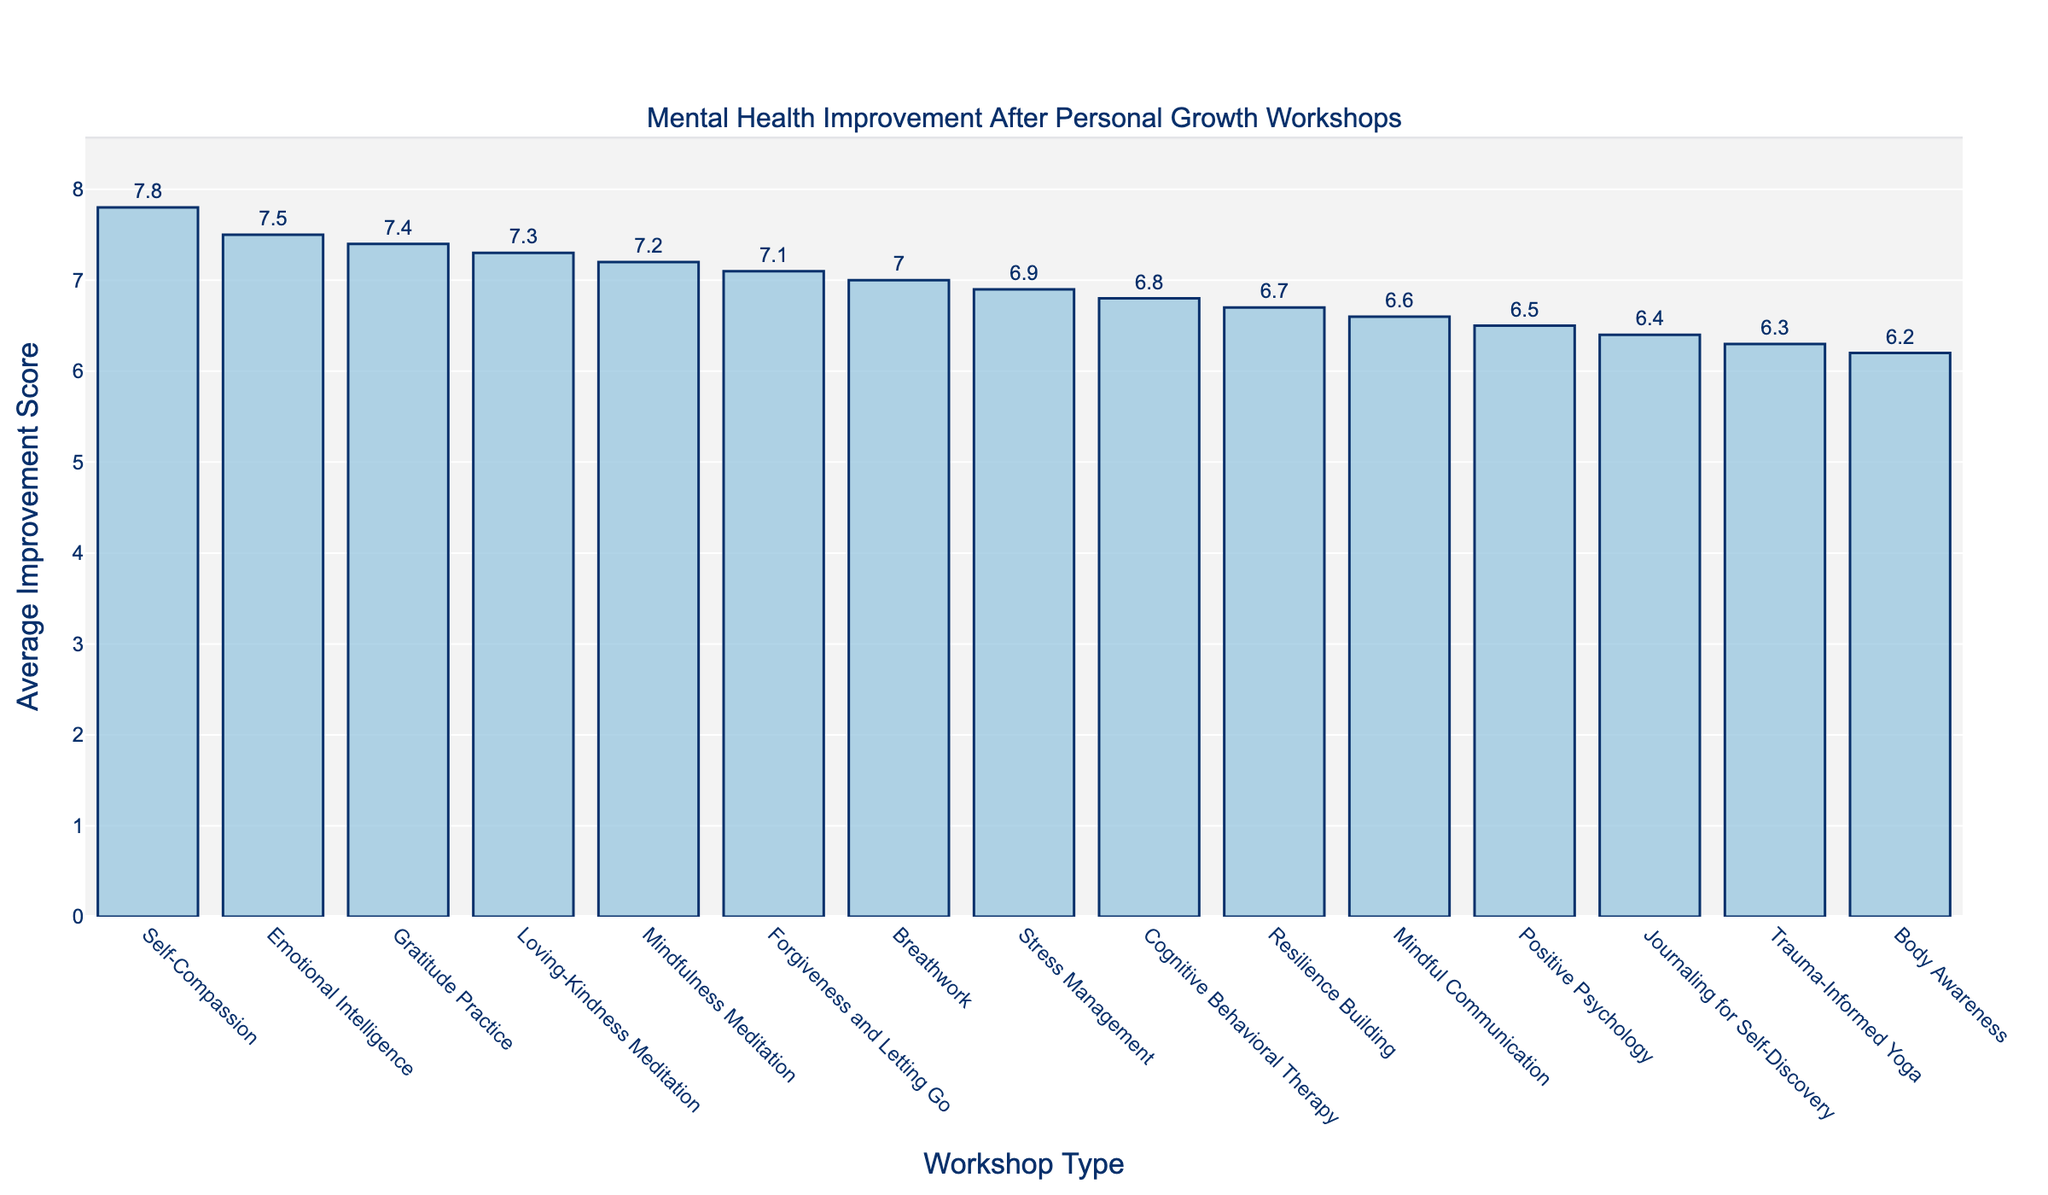Which workshop type has the highest average improvement score? The tallest bar on the chart represents the workshop type with the highest average improvement score. In this case, "Self-Compassion" has the highest bar.
Answer: Self-Compassion Which workshop type has the lowest average improvement score? The shortest bar on the chart indicates the workshop type with the lowest average improvement score. "Body Awareness" has the lowest bar.
Answer: Body Awareness How much higher is the average improvement score of Emotional Intelligence compared to Cognitive Behavioral Therapy? Locate the bars for Emotional Intelligence and Cognitive Behavioral Therapy. Emotional Intelligence has an average improvement score of 7.5, while Cognitive Behavioral Therapy has 6.8. Subtract the lower score from the higher score: 7.5 - 6.8 = 0.7.
Answer: 0.7 What is the combined average improvement score of Mindfulness Meditation and Forgiveness and Letting Go? Find the bars for Mindfulness Meditation and Forgiveness and Letting Go. Their scores are 7.2 and 7.1, respectively. Add these scores together: 7.2 + 7.1 = 14.3.
Answer: 14.3 Rank the workshop types from highest to lowest average improvement scores. Starting from the tallest bar to the shortest, the ranking is: 1) Self-Compassion, 2) Emotional Intelligence, 3) Gratitude Practice, 4) Loving-Kindness Meditation, 5) Mindfulness Meditation, 6) Forgiveness and Letting Go, 7) Breathwork, 8) Stress Management, 9) Cognitive Behavioral Therapy, 10) Resilience Building, 11) Mindful Communication, 12) Journaling for Self-Discovery, 13) Positive Psychology, 14) Body Awareness, 15) Trauma-Informed Yoga.
Answer: Self-Compassion, Emotional Intelligence, Gratitude Practice, Loving-Kindness Meditation, Mindfulness Meditation, Forgiveness and Letting Go, Breathwork, Stress Management, Cognitive Behavioral Therapy, Resilience Building, Mindful Communication, Journaling for Self-Discovery, Positive Psychology, Body Awareness, Trauma-Informed Yoga What is the average improvement score for workshops with scores above 7? Identify the workshops with scores above 7: Mindfulness Meditation (7.2), Emotional Intelligence (7.5), Self-Compassion (7.8), Forgiveness and Letting Go (7.1), Gratitude Practice (7.4), Loving-Kindness Meditation (7.3). Calculate their average: (7.2 + 7.5 + 7.8 + 7.1 + 7.4 + 7.3)/6 = 7.38.
Answer: 7.38 How does the average improvement score of Mindful Communication compare to Journaling for Self-Discovery? Find the bars for Mindful Communication (6.6) and Journaling for Self-Discovery (6.4). The score for Mindful Communication is higher.
Answer: Mindful Communication is higher Which workshop types have an average improvement score that is more than 6.5 but less than 7? Identify the bars fitting this range: Cognitive Behavioral Therapy (6.8), Stress Management (6.9), Resilience Building (6.7), Mindful Communication (6.6), Breathwork (7.0).
Answer: Cognitive Behavioral Therapy, Stress Management, Resilience Building, Mindful Communication, Breathwork Is the difference in average improvement scores between Trauma-Informed Yoga and Positive Psychology larger or smaller than 0.3? Trauma-Informed Yoga has a score of 6.3, Positive Psychology has 6.5. The difference is 6.5 - 6.3 = 0.2, which is smaller than 0.3.
Answer: Smaller If we group the workshops into those with scores above or equal to 7 and those below, how many workshops are in each group? Count the number of workshops with scores >=7 and <7. There are 8 workshops with scores >=7 (Mindfulness Meditation, Emotional Intelligence, Self-Compassion, Forgiveness and Letting Go, Gratitude Practice, Loving-Kindness Meditation, Breathwork, Stress Management) and 7 with scores <7 (Cognitive Behavioral Therapy, Positive Psychology, Mindful Communication, Resilience Building, Journaling for Self-Discovery, Body Awareness, Trauma-Informed Yoga).
Answer: 8 above or equal, 7 below 